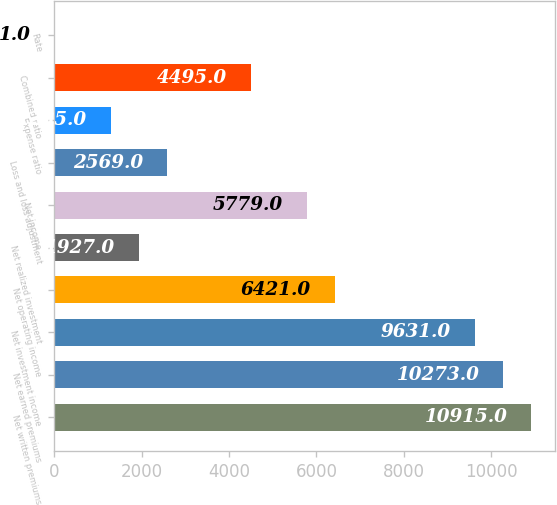Convert chart to OTSL. <chart><loc_0><loc_0><loc_500><loc_500><bar_chart><fcel>Net written premiums<fcel>Net earned premiums<fcel>Net investment income<fcel>Net operating income<fcel>Net realized investment<fcel>Net income<fcel>Loss and loss adjustment<fcel>Expense ratio<fcel>Combined ratio<fcel>Rate<nl><fcel>10915<fcel>10273<fcel>9631<fcel>6421<fcel>1927<fcel>5779<fcel>2569<fcel>1285<fcel>4495<fcel>1<nl></chart> 